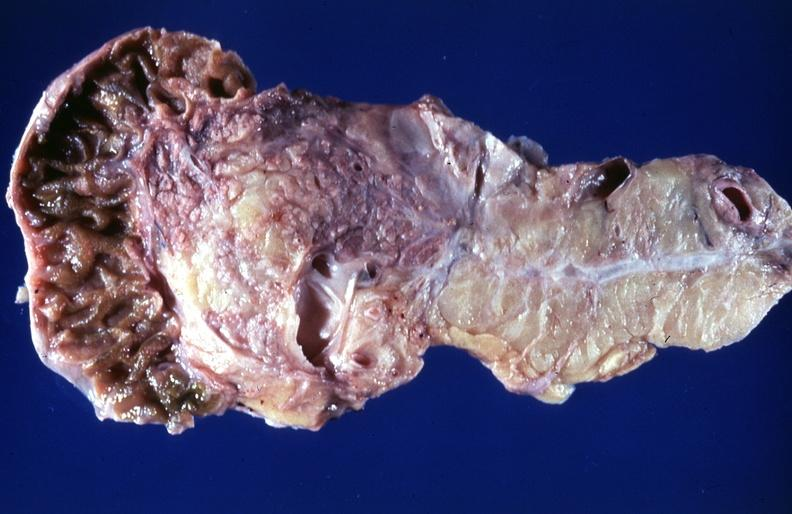does this image show cystic fibrosis?
Answer the question using a single word or phrase. Yes 